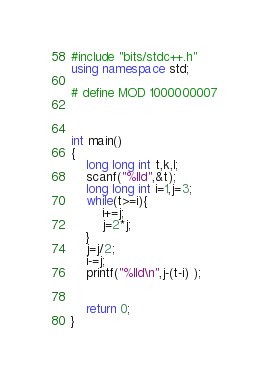<code> <loc_0><loc_0><loc_500><loc_500><_C++_>#include "bits/stdc++.h"
using namespace std;

# define MOD 1000000007



int main()
{
	long long int t,k,l;
	scanf("%lld",&t);
	long long int i=1,j=3;
	while(t>=i){
		i+=j;
		j=2*j;
	}
	j=j/2;
	i-=j;
	printf("%lld\n",j-(t-i) );


	return 0;
}
	</code> 